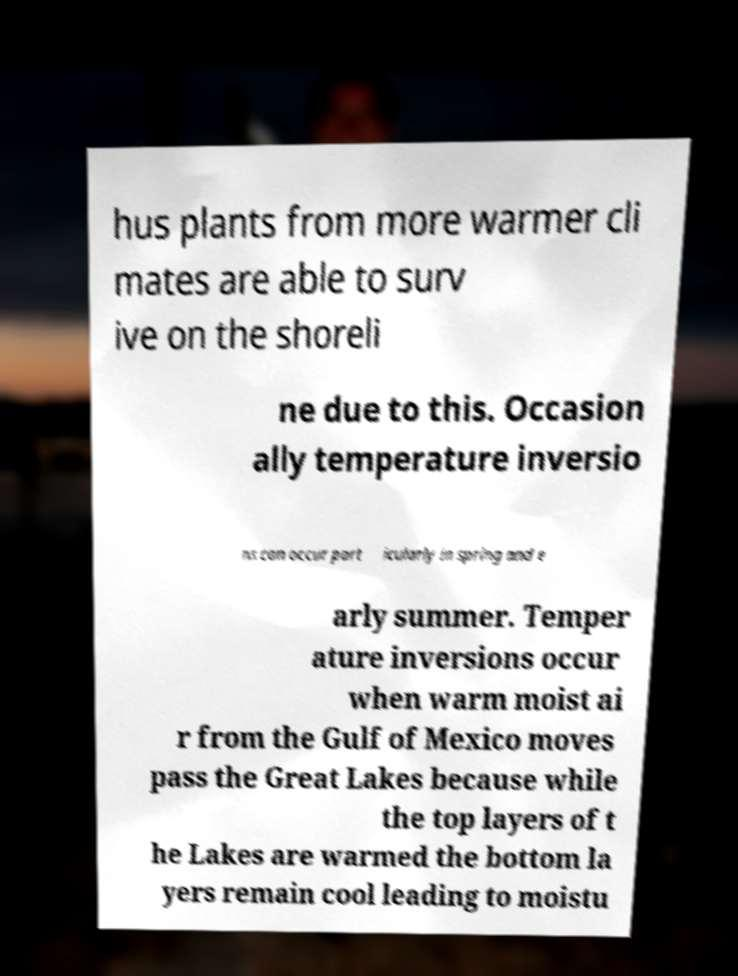I need the written content from this picture converted into text. Can you do that? hus plants from more warmer cli mates are able to surv ive on the shoreli ne due to this. Occasion ally temperature inversio ns can occur part icularly in spring and e arly summer. Temper ature inversions occur when warm moist ai r from the Gulf of Mexico moves pass the Great Lakes because while the top layers of t he Lakes are warmed the bottom la yers remain cool leading to moistu 